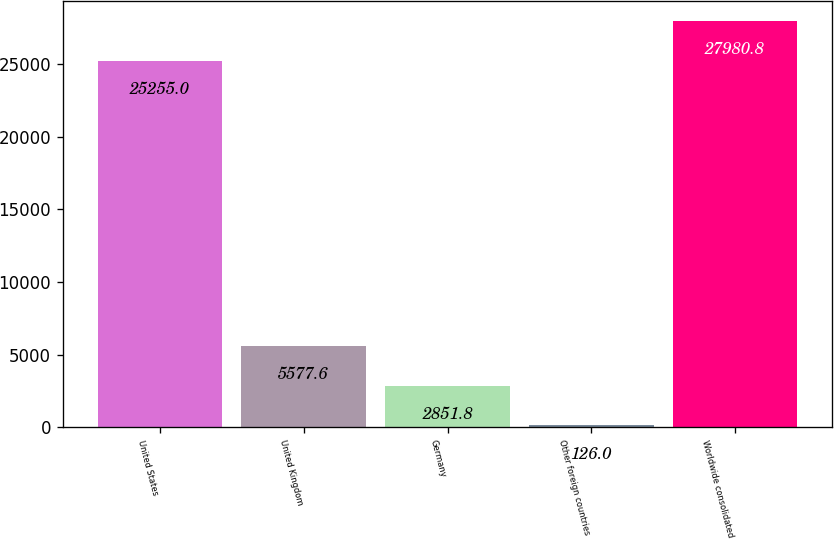Convert chart to OTSL. <chart><loc_0><loc_0><loc_500><loc_500><bar_chart><fcel>United States<fcel>United Kingdom<fcel>Germany<fcel>Other foreign countries<fcel>Worldwide consolidated<nl><fcel>25255<fcel>5577.6<fcel>2851.8<fcel>126<fcel>27980.8<nl></chart> 